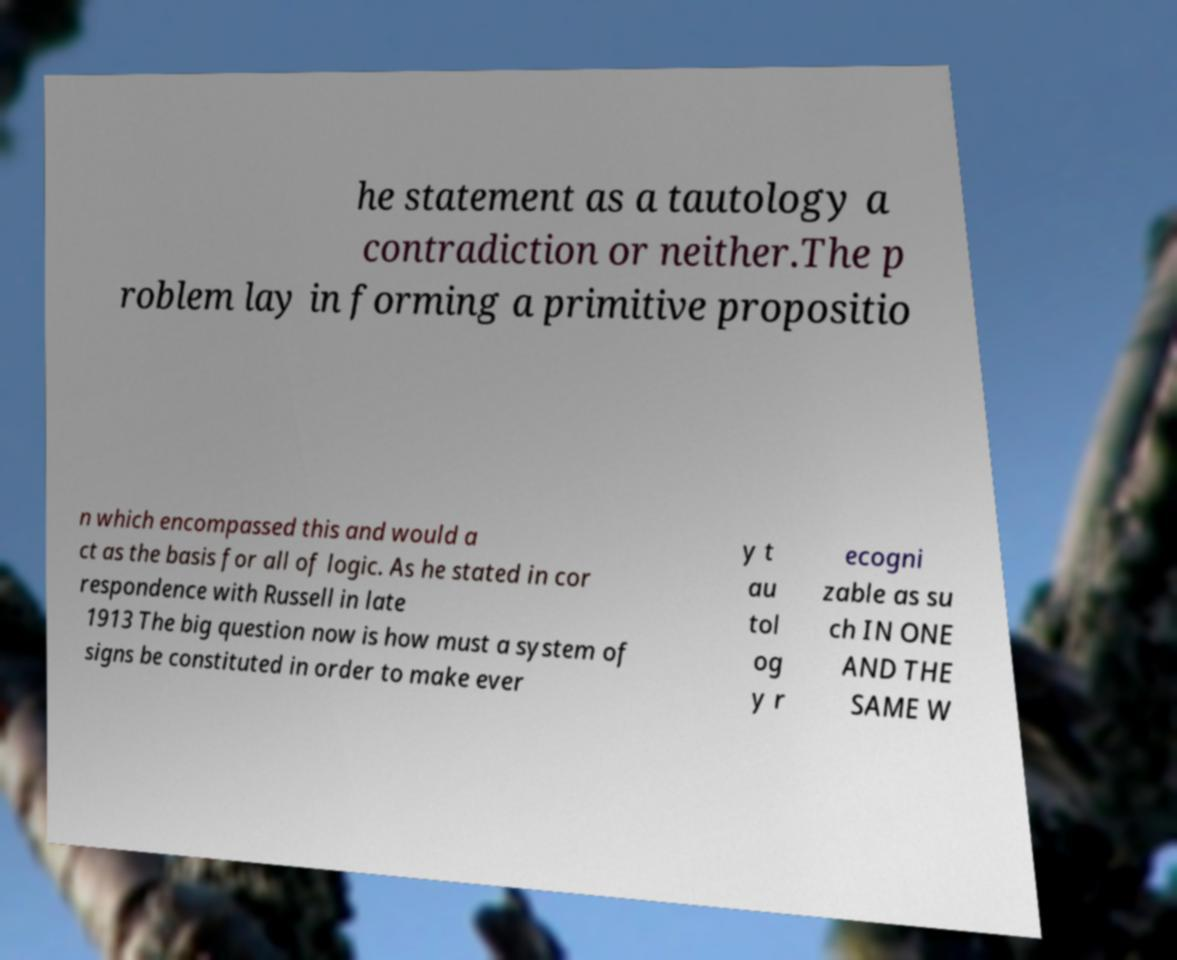Please identify and transcribe the text found in this image. he statement as a tautology a contradiction or neither.The p roblem lay in forming a primitive propositio n which encompassed this and would a ct as the basis for all of logic. As he stated in cor respondence with Russell in late 1913 The big question now is how must a system of signs be constituted in order to make ever y t au tol og y r ecogni zable as su ch IN ONE AND THE SAME W 